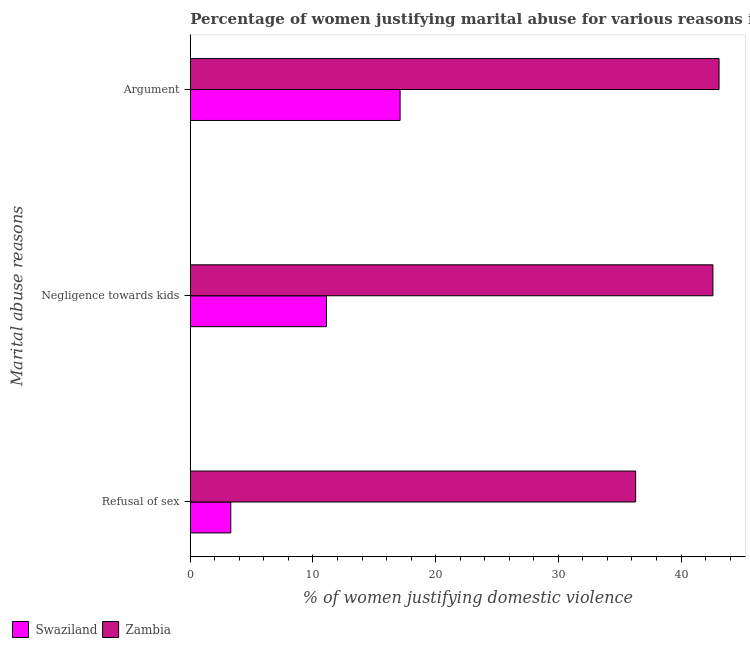Are the number of bars on each tick of the Y-axis equal?
Offer a very short reply. Yes. What is the label of the 3rd group of bars from the top?
Give a very brief answer. Refusal of sex. What is the percentage of women justifying domestic violence due to arguments in Zambia?
Provide a succinct answer. 43.1. Across all countries, what is the maximum percentage of women justifying domestic violence due to arguments?
Keep it short and to the point. 43.1. In which country was the percentage of women justifying domestic violence due to arguments maximum?
Your answer should be very brief. Zambia. In which country was the percentage of women justifying domestic violence due to arguments minimum?
Provide a succinct answer. Swaziland. What is the total percentage of women justifying domestic violence due to refusal of sex in the graph?
Your answer should be very brief. 39.6. What is the difference between the percentage of women justifying domestic violence due to refusal of sex in Swaziland and that in Zambia?
Provide a short and direct response. -33. What is the difference between the percentage of women justifying domestic violence due to refusal of sex in Swaziland and the percentage of women justifying domestic violence due to arguments in Zambia?
Your answer should be compact. -39.8. What is the average percentage of women justifying domestic violence due to negligence towards kids per country?
Keep it short and to the point. 26.85. What is the difference between the percentage of women justifying domestic violence due to arguments and percentage of women justifying domestic violence due to negligence towards kids in Swaziland?
Provide a succinct answer. 6. In how many countries, is the percentage of women justifying domestic violence due to negligence towards kids greater than 36 %?
Make the answer very short. 1. What is the ratio of the percentage of women justifying domestic violence due to refusal of sex in Swaziland to that in Zambia?
Provide a short and direct response. 0.09. Is the difference between the percentage of women justifying domestic violence due to refusal of sex in Swaziland and Zambia greater than the difference between the percentage of women justifying domestic violence due to arguments in Swaziland and Zambia?
Give a very brief answer. No. What is the difference between the highest and the second highest percentage of women justifying domestic violence due to arguments?
Provide a short and direct response. 26. What is the difference between the highest and the lowest percentage of women justifying domestic violence due to arguments?
Your answer should be compact. 26. What does the 2nd bar from the top in Refusal of sex represents?
Offer a very short reply. Swaziland. What does the 2nd bar from the bottom in Argument represents?
Give a very brief answer. Zambia. How many countries are there in the graph?
Your answer should be compact. 2. Where does the legend appear in the graph?
Offer a terse response. Bottom left. How are the legend labels stacked?
Give a very brief answer. Horizontal. What is the title of the graph?
Your answer should be compact. Percentage of women justifying marital abuse for various reasons in countries in 2007. Does "Oman" appear as one of the legend labels in the graph?
Ensure brevity in your answer.  No. What is the label or title of the X-axis?
Your response must be concise. % of women justifying domestic violence. What is the label or title of the Y-axis?
Offer a terse response. Marital abuse reasons. What is the % of women justifying domestic violence in Zambia in Refusal of sex?
Your answer should be very brief. 36.3. What is the % of women justifying domestic violence of Swaziland in Negligence towards kids?
Provide a succinct answer. 11.1. What is the % of women justifying domestic violence of Zambia in Negligence towards kids?
Provide a short and direct response. 42.6. What is the % of women justifying domestic violence of Swaziland in Argument?
Your answer should be very brief. 17.1. What is the % of women justifying domestic violence in Zambia in Argument?
Ensure brevity in your answer.  43.1. Across all Marital abuse reasons, what is the maximum % of women justifying domestic violence of Swaziland?
Your response must be concise. 17.1. Across all Marital abuse reasons, what is the maximum % of women justifying domestic violence of Zambia?
Offer a terse response. 43.1. Across all Marital abuse reasons, what is the minimum % of women justifying domestic violence of Swaziland?
Offer a terse response. 3.3. Across all Marital abuse reasons, what is the minimum % of women justifying domestic violence of Zambia?
Your response must be concise. 36.3. What is the total % of women justifying domestic violence of Swaziland in the graph?
Your response must be concise. 31.5. What is the total % of women justifying domestic violence in Zambia in the graph?
Offer a very short reply. 122. What is the difference between the % of women justifying domestic violence of Zambia in Refusal of sex and that in Negligence towards kids?
Offer a terse response. -6.3. What is the difference between the % of women justifying domestic violence of Zambia in Refusal of sex and that in Argument?
Offer a terse response. -6.8. What is the difference between the % of women justifying domestic violence in Zambia in Negligence towards kids and that in Argument?
Ensure brevity in your answer.  -0.5. What is the difference between the % of women justifying domestic violence of Swaziland in Refusal of sex and the % of women justifying domestic violence of Zambia in Negligence towards kids?
Your answer should be very brief. -39.3. What is the difference between the % of women justifying domestic violence in Swaziland in Refusal of sex and the % of women justifying domestic violence in Zambia in Argument?
Your response must be concise. -39.8. What is the difference between the % of women justifying domestic violence of Swaziland in Negligence towards kids and the % of women justifying domestic violence of Zambia in Argument?
Your answer should be very brief. -32. What is the average % of women justifying domestic violence in Swaziland per Marital abuse reasons?
Your answer should be very brief. 10.5. What is the average % of women justifying domestic violence in Zambia per Marital abuse reasons?
Ensure brevity in your answer.  40.67. What is the difference between the % of women justifying domestic violence of Swaziland and % of women justifying domestic violence of Zambia in Refusal of sex?
Provide a succinct answer. -33. What is the difference between the % of women justifying domestic violence of Swaziland and % of women justifying domestic violence of Zambia in Negligence towards kids?
Offer a very short reply. -31.5. What is the ratio of the % of women justifying domestic violence of Swaziland in Refusal of sex to that in Negligence towards kids?
Your answer should be very brief. 0.3. What is the ratio of the % of women justifying domestic violence of Zambia in Refusal of sex to that in Negligence towards kids?
Keep it short and to the point. 0.85. What is the ratio of the % of women justifying domestic violence in Swaziland in Refusal of sex to that in Argument?
Keep it short and to the point. 0.19. What is the ratio of the % of women justifying domestic violence in Zambia in Refusal of sex to that in Argument?
Ensure brevity in your answer.  0.84. What is the ratio of the % of women justifying domestic violence of Swaziland in Negligence towards kids to that in Argument?
Provide a short and direct response. 0.65. What is the ratio of the % of women justifying domestic violence in Zambia in Negligence towards kids to that in Argument?
Keep it short and to the point. 0.99. What is the difference between the highest and the second highest % of women justifying domestic violence in Zambia?
Ensure brevity in your answer.  0.5. What is the difference between the highest and the lowest % of women justifying domestic violence of Swaziland?
Ensure brevity in your answer.  13.8. 